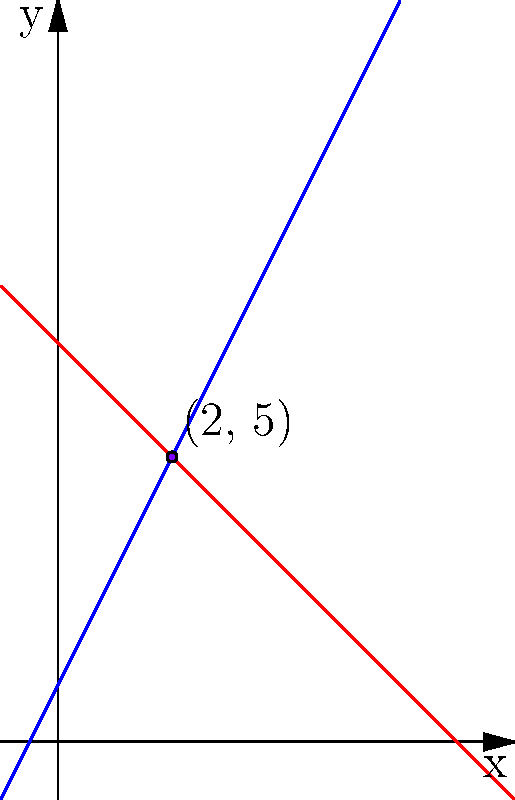As an Information Security Consultant, you're analyzing the intersection of two security perimeters in a cyber-physical system. Perimeter A is represented by the equation $y = 2x + 1$, and Perimeter B is represented by $y = -x + 7$. At what point do these perimeters intersect, and what is the sum of the x and y coordinates of this intersection point? This sum could represent a critical security threshold in your analysis. To solve this problem, we need to follow these steps:

1) First, we need to find the point of intersection of the two lines representing the security perimeters.

2) To do this, we set the equations equal to each other:

   $$2x + 1 = -x + 7$$

3) Now, we solve for x:

   $$2x + 1 = -x + 7$$
   $$3x = 6$$
   $$x = 2$$

4) We can find y by plugging x = 2 into either of the original equations. Let's use the first one:

   $$y = 2(2) + 1 = 4 + 1 = 5$$

5) So, the point of intersection is (2, 5).

6) The question asks for the sum of the x and y coordinates:

   $$2 + 5 = 7$$

Therefore, the sum of the x and y coordinates of the intersection point is 7.
Answer: 7 